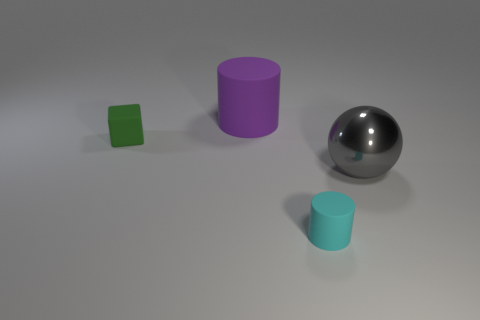Can you describe the texture and finish of each object in the image? Certainly! The large purple cylinder has a matte finish, diffusing light and giving it a non-reflective appearance. The tiny green block also has a matte texture, looking slightly rough and non-glossy. The rubber cylinder on the right appears to have a bit of a sheen, indicating a semi-matte finish. Lastly, the sphere in the center is highly reflective with a metallic finish, mirroring its environment on its polished surface. 